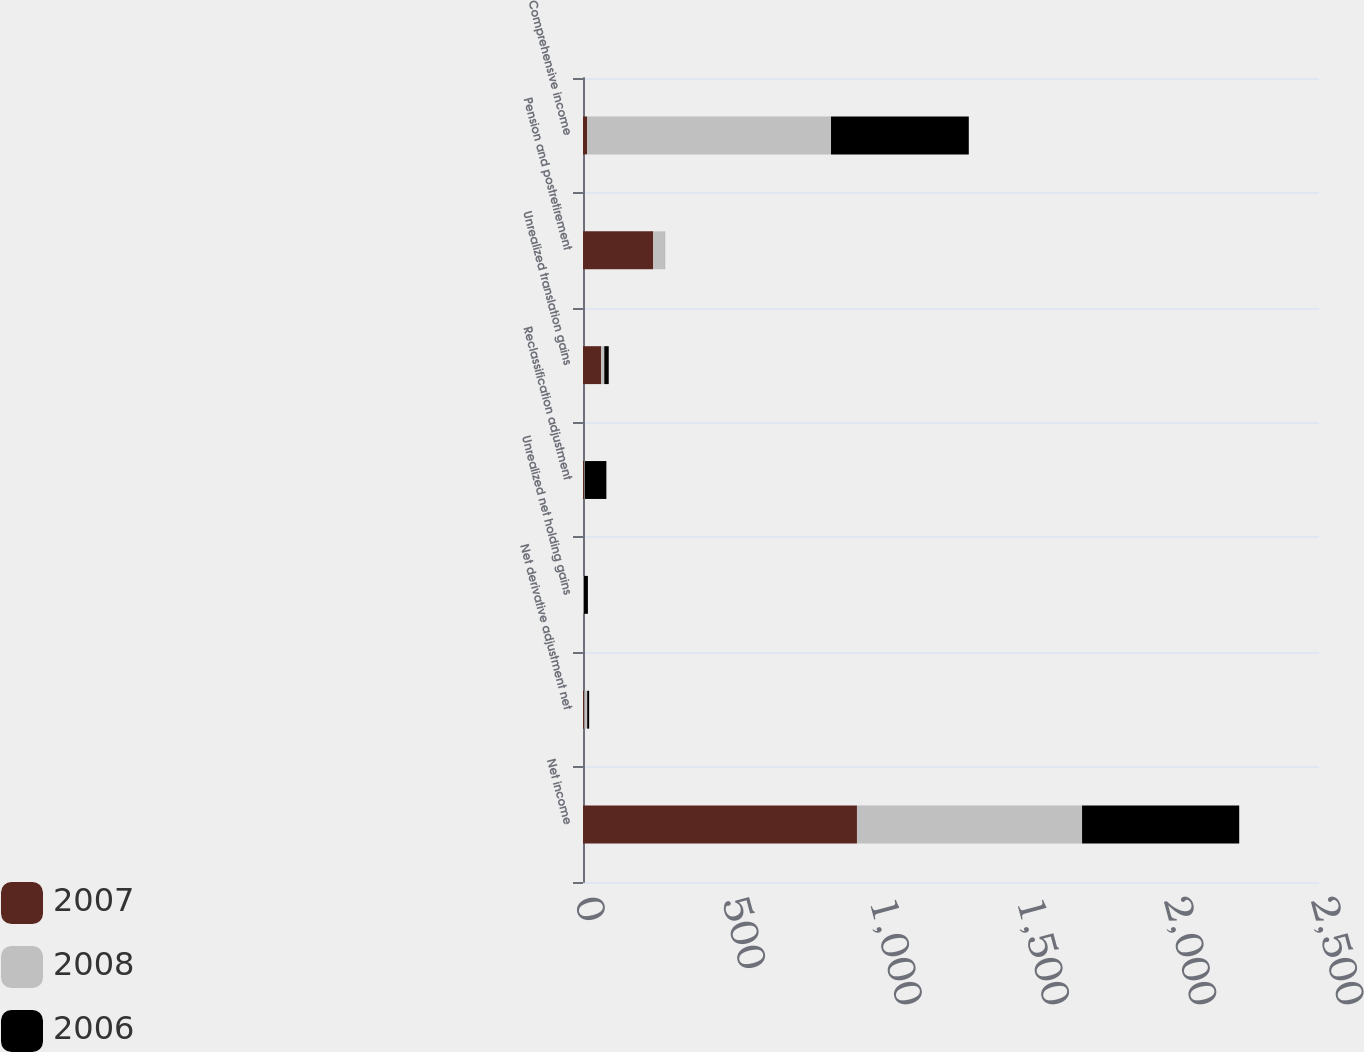Convert chart. <chart><loc_0><loc_0><loc_500><loc_500><stacked_bar_chart><ecel><fcel>Net income<fcel>Net derivative adjustment net<fcel>Unrealized net holding gains<fcel>Reclassification adjustment<fcel>Unrealized translation gains<fcel>Pension and postretirement<fcel>Comprehensive income<nl><fcel>2007<fcel>930.6<fcel>4.9<fcel>0.4<fcel>3.8<fcel>61.3<fcel>238.6<fcel>14.45<nl><fcel>2008<fcel>764.6<fcel>9.4<fcel>2.5<fcel>2.2<fcel>11<fcel>39.8<fcel>828<nl><fcel>2006<fcel>533.8<fcel>6.6<fcel>13.8<fcel>73.4<fcel>15.1<fcel>0.3<fcel>468<nl></chart> 